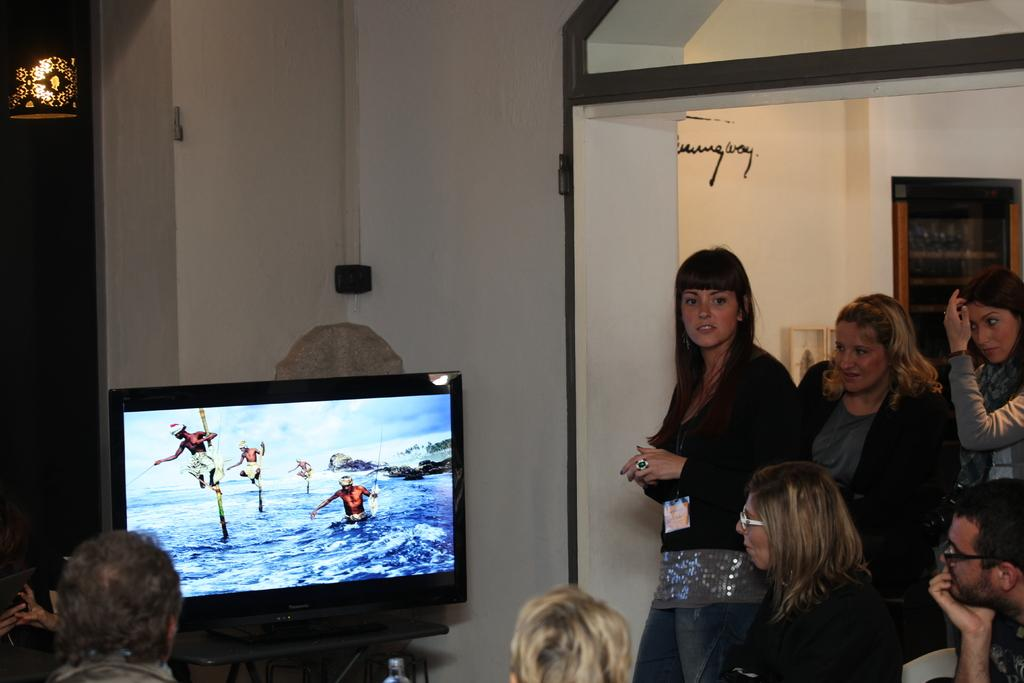What is the main subject of the image? The main subject of the image is a group of people. How can you describe the appearance of the people in the image? The people are wearing different color dresses. What is in front of the people in the image? There is a screen in front of the people. What can be seen in the background of the image? There is a wall in the background of the image. Can you see any ants crawling on the people's dresses in the image? There are no ants visible on the people's dresses in the image. What type of wrench is being used by the people in the image? There is no wrench present in the image; the people are wearing different color dresses and standing in front of a screen. 